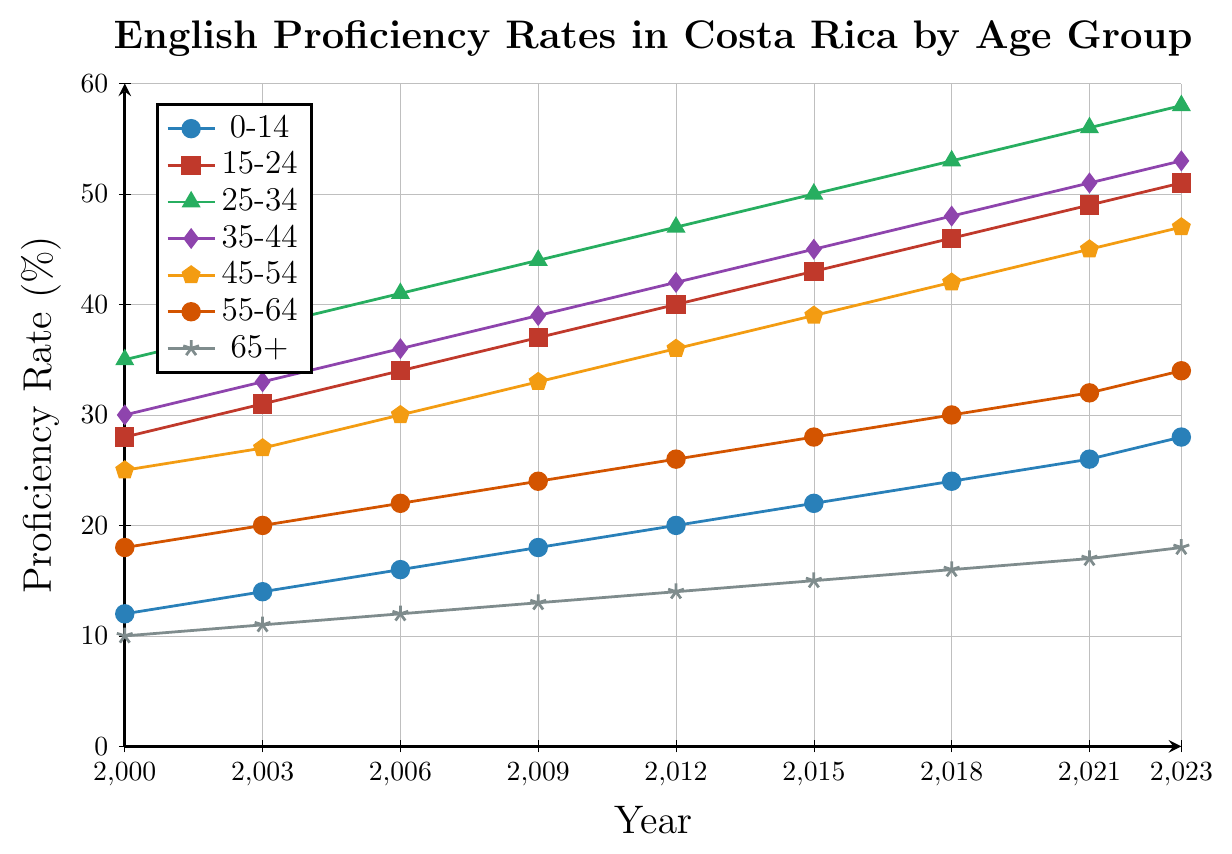What is the proficiency rate for the age 25-34 group in the year 2023? Find the point for the 25-34 group at the year 2023 on the chart. The line marked with triangle symbols shows a value of 58.
Answer: 58 Which age group has the highest English proficiency rate in 2023? Look at the axis labels and find the highest point for the year 2023. The 25-34 age group has the highest value.
Answer: 25-34 By how much did the English proficiency rate for the 0-14 age group increase from 2000 to 2023? Subtract the 2000 proficiency rate for the 0-14 group (12) from the 2023 rate (28). The increase is 28 - 12.
Answer: 16 Compare the proficiency rates of the 45-54 and 55-64 age groups in 2015. Which group has higher proficiency and by how much? Find the proficiency rates for both groups in 2015: 45-54 is 39, and 55-64 is 28. Subtract 28 from 39 to find the difference.
Answer: 45-54, 11 What is the average proficiency rate of the 35-44 age group from 2000 to 2023? Add the values for the years 2000 to 2023 (30+33+36+39+42+45+48+51+53) and divide by the number of years (9).
Answer: 42.9 How did the proficiency rate for the 15-24 age group change from 2000 to 2023? Subtract the proficiency rate in 2000 (28) from the rate in 2023 (51). The increase is 51 - 28.
Answer: 23 In which year did the 65+ age group have a proficiency rate of 15%? Find the point for the 65+ age group line that corresponds to 15%. This value is found at the year 2015.
Answer: 2015 Compare the increase rates between the 25-34 and 0-14 age groups from 2000 to 2023. Which age group increased more and by how much? Subtract the 2000 rate from the 2023 rate for both age groups. For 0-14, it is 28 - 12 = 16. For 25-34, it is 58 - 35 = 23. The 25-34 group increased by 23 - 16.
Answer: 25-34, 7 What was the proficiency rate of the 55-64 age group in 2012? Find the value for the 55-64 age group at the year 2012 on the chart. The point shows a value of 26.
Answer: 26 